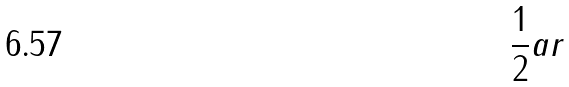<formula> <loc_0><loc_0><loc_500><loc_500>\frac { 1 } { 2 } a r</formula> 